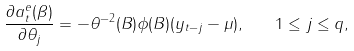<formula> <loc_0><loc_0><loc_500><loc_500>\frac { \partial a _ { t } ^ { e } ( \beta ) } { \partial \theta _ { j } } = - \theta ^ { - 2 } ( B ) \phi ( B ) ( y _ { t - j } - \mu ) , \quad 1 \leq j \leq q ,</formula> 